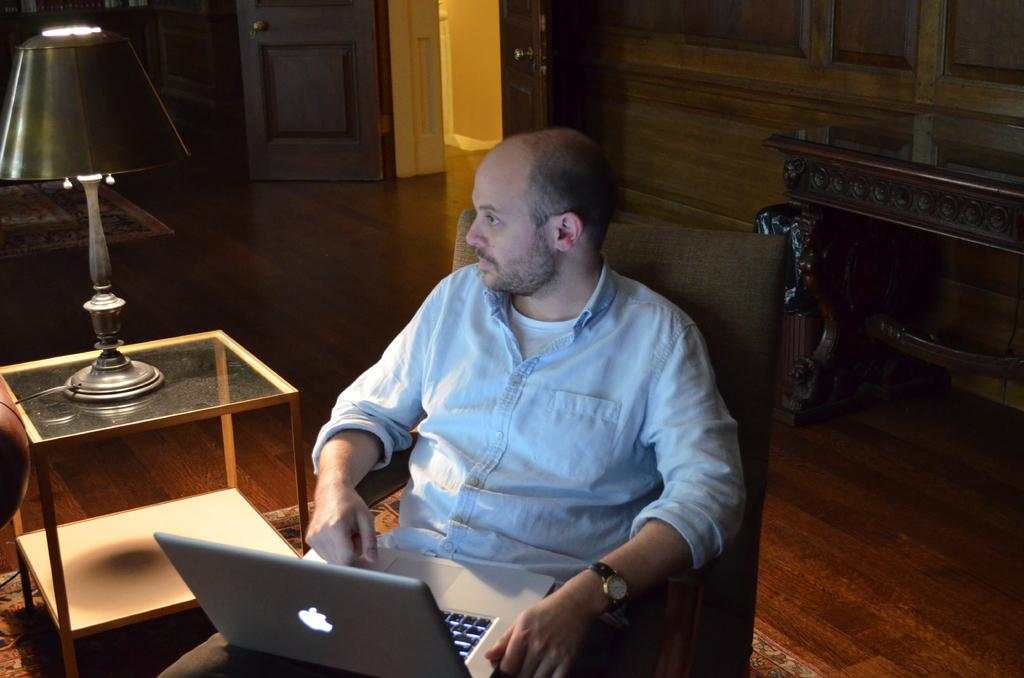What is the main subject of the image? There is a man in the image. What is the man doing in the image? The man is sitting on a chair. What object does the man have on his lap? The man has a laptop on his lap. What is located next to the man? There is a table next to the man. What is on the table? There is a lamp on the table. What can be seen in the background of the image? There is a door visible in the background of the image. What type of locket is the man wearing around his neck in the image? There is no locket visible around the man's neck in the image. 